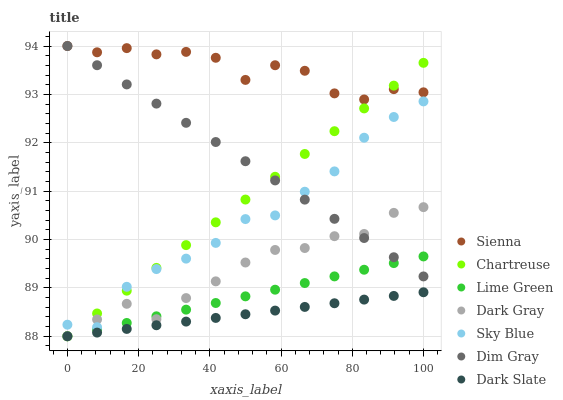Does Dark Slate have the minimum area under the curve?
Answer yes or no. Yes. Does Sienna have the maximum area under the curve?
Answer yes or no. Yes. Does Dim Gray have the minimum area under the curve?
Answer yes or no. No. Does Dim Gray have the maximum area under the curve?
Answer yes or no. No. Is Lime Green the smoothest?
Answer yes or no. Yes. Is Sienna the roughest?
Answer yes or no. Yes. Is Dim Gray the smoothest?
Answer yes or no. No. Is Dim Gray the roughest?
Answer yes or no. No. Does Dark Gray have the lowest value?
Answer yes or no. Yes. Does Dim Gray have the lowest value?
Answer yes or no. No. Does Sienna have the highest value?
Answer yes or no. Yes. Does Dark Slate have the highest value?
Answer yes or no. No. Is Dark Slate less than Dim Gray?
Answer yes or no. Yes. Is Sienna greater than Dark Gray?
Answer yes or no. Yes. Does Sienna intersect Chartreuse?
Answer yes or no. Yes. Is Sienna less than Chartreuse?
Answer yes or no. No. Is Sienna greater than Chartreuse?
Answer yes or no. No. Does Dark Slate intersect Dim Gray?
Answer yes or no. No. 